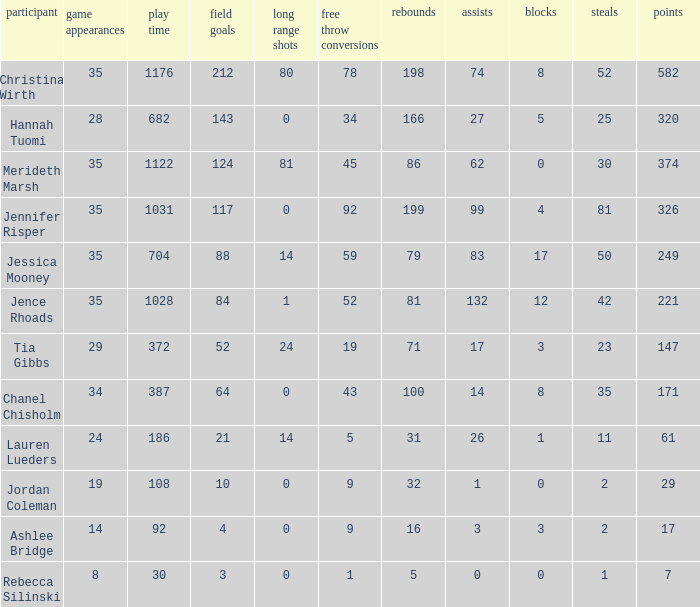What is the lowest number of games played by the player with 50 steals? 35.0. 